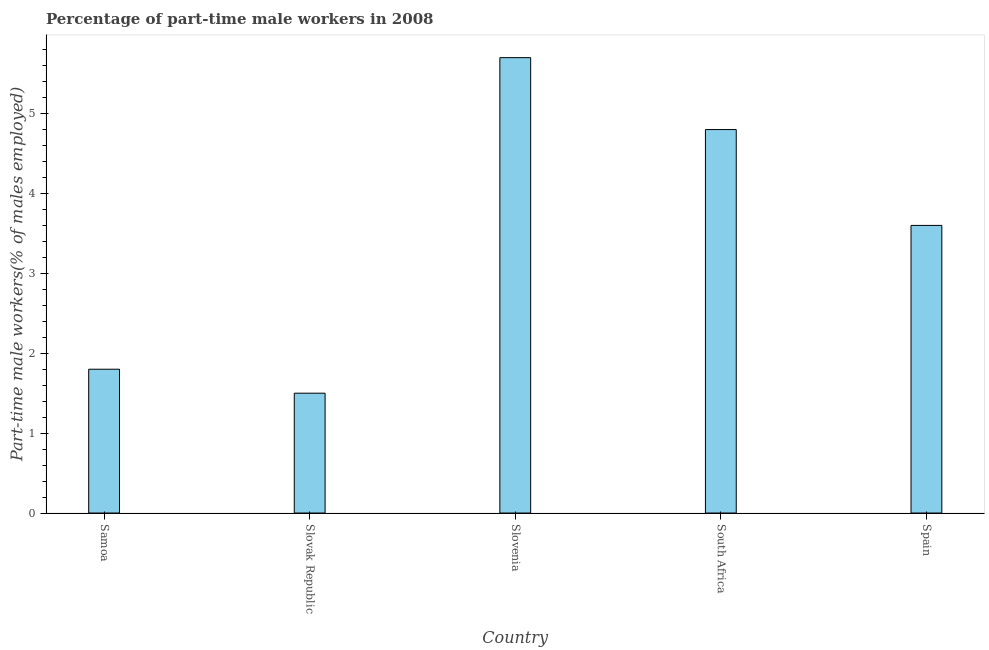Does the graph contain any zero values?
Your answer should be compact. No. What is the title of the graph?
Provide a short and direct response. Percentage of part-time male workers in 2008. What is the label or title of the Y-axis?
Make the answer very short. Part-time male workers(% of males employed). What is the percentage of part-time male workers in Spain?
Keep it short and to the point. 3.6. Across all countries, what is the maximum percentage of part-time male workers?
Provide a succinct answer. 5.7. Across all countries, what is the minimum percentage of part-time male workers?
Your answer should be compact. 1.5. In which country was the percentage of part-time male workers maximum?
Offer a very short reply. Slovenia. In which country was the percentage of part-time male workers minimum?
Your response must be concise. Slovak Republic. What is the sum of the percentage of part-time male workers?
Give a very brief answer. 17.4. What is the average percentage of part-time male workers per country?
Give a very brief answer. 3.48. What is the median percentage of part-time male workers?
Your answer should be compact. 3.6. What is the ratio of the percentage of part-time male workers in Samoa to that in Slovenia?
Keep it short and to the point. 0.32. Is the percentage of part-time male workers in South Africa less than that in Spain?
Provide a succinct answer. No. Is the difference between the percentage of part-time male workers in Slovenia and South Africa greater than the difference between any two countries?
Make the answer very short. No. Is the sum of the percentage of part-time male workers in Slovak Republic and Slovenia greater than the maximum percentage of part-time male workers across all countries?
Give a very brief answer. Yes. What is the difference between the highest and the lowest percentage of part-time male workers?
Offer a very short reply. 4.2. Are all the bars in the graph horizontal?
Offer a very short reply. No. Are the values on the major ticks of Y-axis written in scientific E-notation?
Your response must be concise. No. What is the Part-time male workers(% of males employed) in Samoa?
Keep it short and to the point. 1.8. What is the Part-time male workers(% of males employed) of Slovak Republic?
Offer a terse response. 1.5. What is the Part-time male workers(% of males employed) of Slovenia?
Your response must be concise. 5.7. What is the Part-time male workers(% of males employed) of South Africa?
Offer a terse response. 4.8. What is the Part-time male workers(% of males employed) in Spain?
Provide a short and direct response. 3.6. What is the difference between the Part-time male workers(% of males employed) in Samoa and Slovak Republic?
Provide a succinct answer. 0.3. What is the difference between the Part-time male workers(% of males employed) in Samoa and South Africa?
Make the answer very short. -3. What is the difference between the Part-time male workers(% of males employed) in Samoa and Spain?
Offer a very short reply. -1.8. What is the difference between the Part-time male workers(% of males employed) in Slovak Republic and Slovenia?
Offer a very short reply. -4.2. What is the difference between the Part-time male workers(% of males employed) in Slovak Republic and South Africa?
Your answer should be very brief. -3.3. What is the difference between the Part-time male workers(% of males employed) in Slovak Republic and Spain?
Your answer should be very brief. -2.1. What is the ratio of the Part-time male workers(% of males employed) in Samoa to that in Slovenia?
Ensure brevity in your answer.  0.32. What is the ratio of the Part-time male workers(% of males employed) in Slovak Republic to that in Slovenia?
Your response must be concise. 0.26. What is the ratio of the Part-time male workers(% of males employed) in Slovak Republic to that in South Africa?
Your response must be concise. 0.31. What is the ratio of the Part-time male workers(% of males employed) in Slovak Republic to that in Spain?
Ensure brevity in your answer.  0.42. What is the ratio of the Part-time male workers(% of males employed) in Slovenia to that in South Africa?
Make the answer very short. 1.19. What is the ratio of the Part-time male workers(% of males employed) in Slovenia to that in Spain?
Offer a very short reply. 1.58. What is the ratio of the Part-time male workers(% of males employed) in South Africa to that in Spain?
Keep it short and to the point. 1.33. 